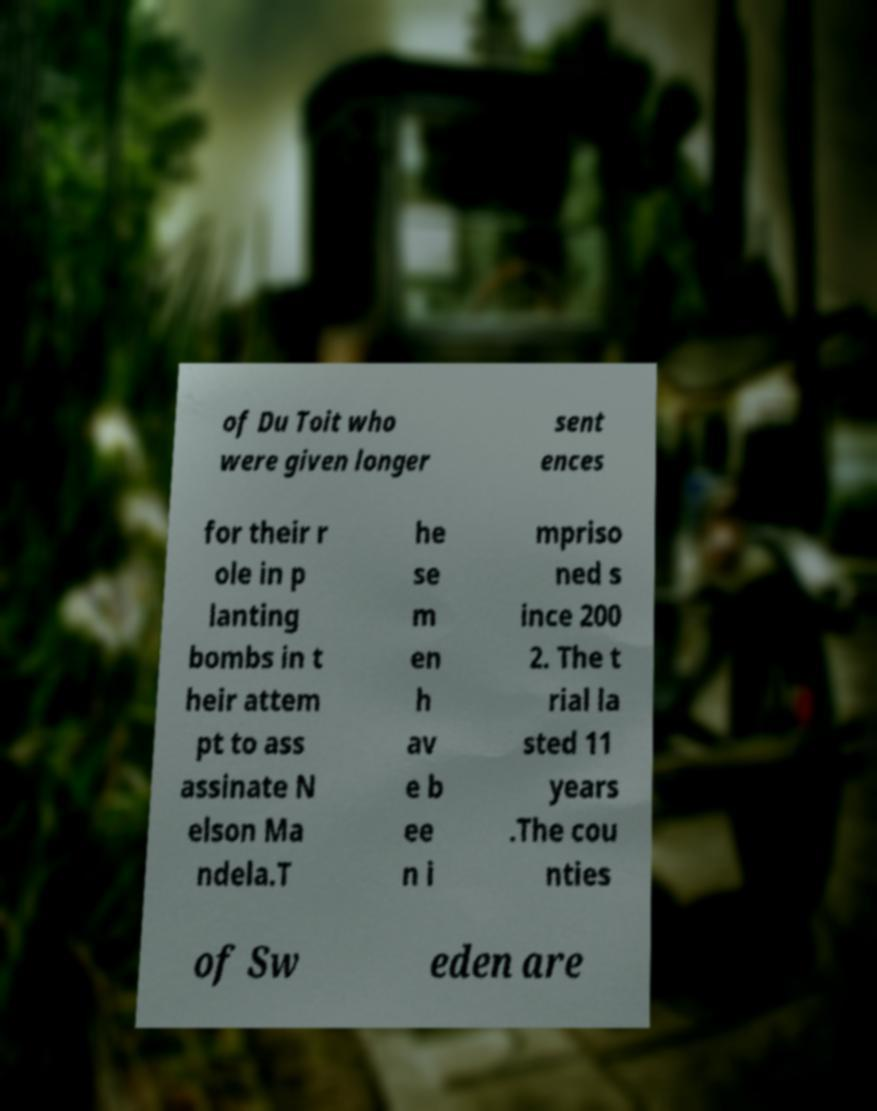Can you read and provide the text displayed in the image?This photo seems to have some interesting text. Can you extract and type it out for me? of Du Toit who were given longer sent ences for their r ole in p lanting bombs in t heir attem pt to ass assinate N elson Ma ndela.T he se m en h av e b ee n i mpriso ned s ince 200 2. The t rial la sted 11 years .The cou nties of Sw eden are 